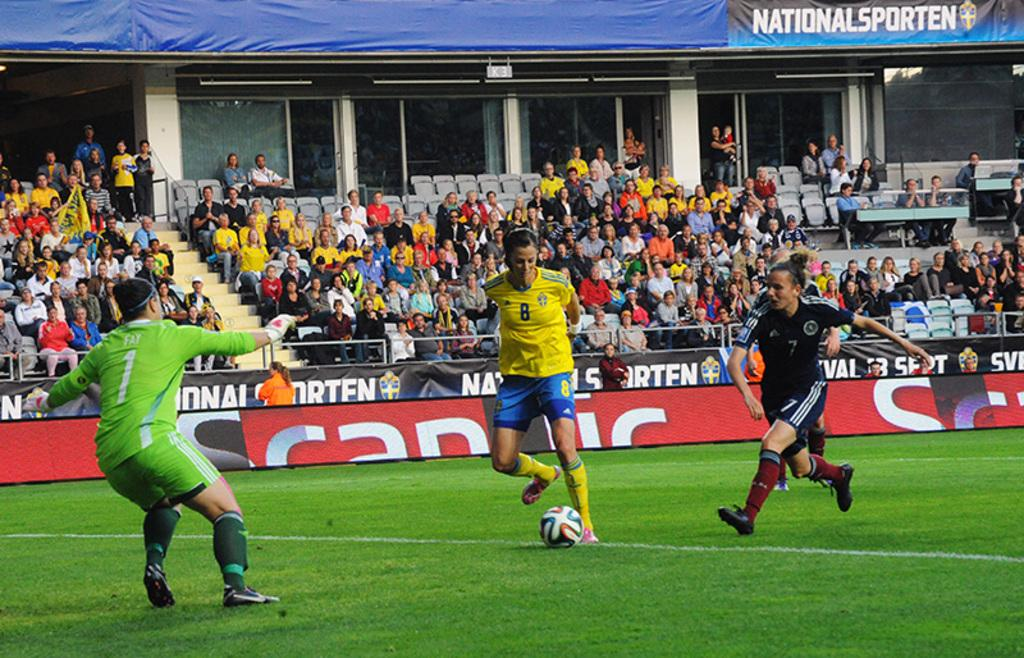<image>
Describe the image concisely. The player in the green jersey is number 1 